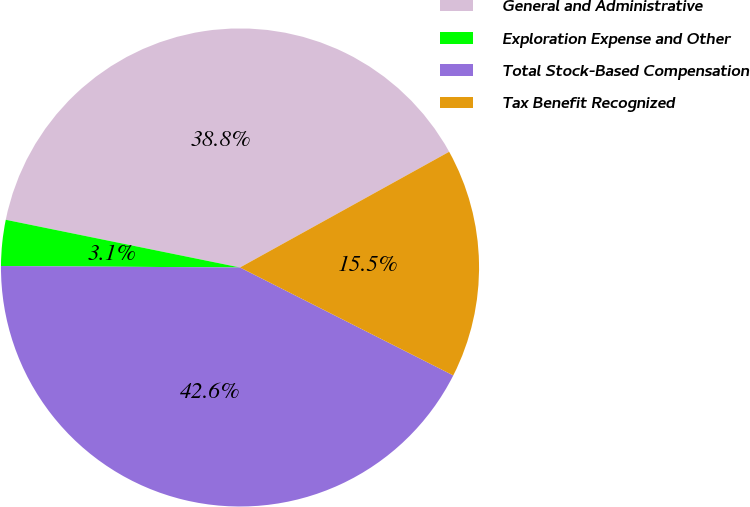Convert chart. <chart><loc_0><loc_0><loc_500><loc_500><pie_chart><fcel>General and Administrative<fcel>Exploration Expense and Other<fcel>Total Stock-Based Compensation<fcel>Tax Benefit Recognized<nl><fcel>38.76%<fcel>3.1%<fcel>42.64%<fcel>15.5%<nl></chart> 